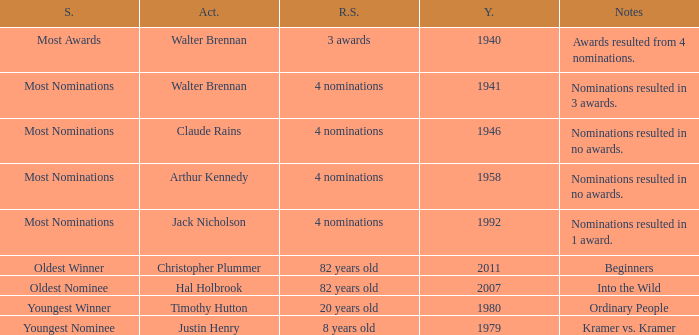What is the earliest year for ordinary people to appear in the notes? 1980.0. Help me parse the entirety of this table. {'header': ['S.', 'Act.', 'R.S.', 'Y.', 'Notes'], 'rows': [['Most Awards', 'Walter Brennan', '3 awards', '1940', 'Awards resulted from 4 nominations.'], ['Most Nominations', 'Walter Brennan', '4 nominations', '1941', 'Nominations resulted in 3 awards.'], ['Most Nominations', 'Claude Rains', '4 nominations', '1946', 'Nominations resulted in no awards.'], ['Most Nominations', 'Arthur Kennedy', '4 nominations', '1958', 'Nominations resulted in no awards.'], ['Most Nominations', 'Jack Nicholson', '4 nominations', '1992', 'Nominations resulted in 1 award.'], ['Oldest Winner', 'Christopher Plummer', '82 years old', '2011', 'Beginners'], ['Oldest Nominee', 'Hal Holbrook', '82 years old', '2007', 'Into the Wild'], ['Youngest Winner', 'Timothy Hutton', '20 years old', '1980', 'Ordinary People'], ['Youngest Nominee', 'Justin Henry', '8 years old', '1979', 'Kramer vs. Kramer']]} 